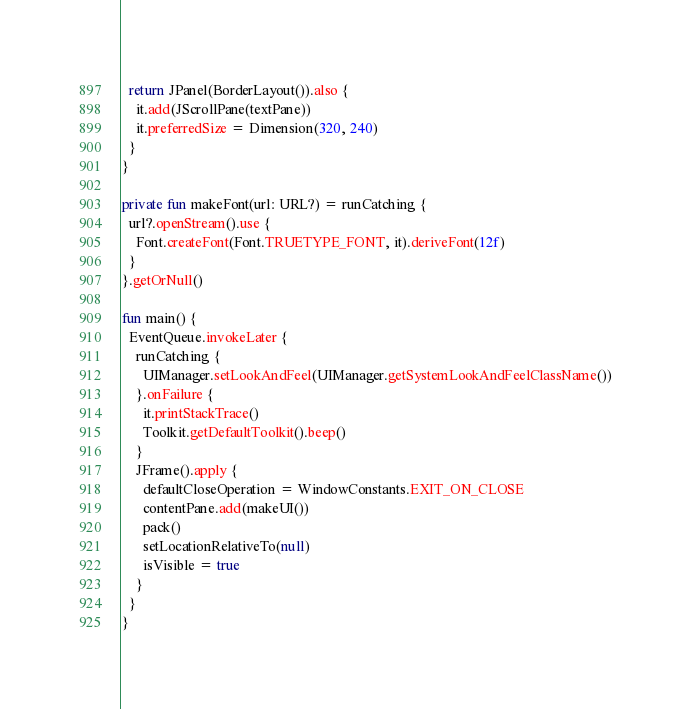<code> <loc_0><loc_0><loc_500><loc_500><_Kotlin_>  return JPanel(BorderLayout()).also {
    it.add(JScrollPane(textPane))
    it.preferredSize = Dimension(320, 240)
  }
}

private fun makeFont(url: URL?) = runCatching {
  url?.openStream().use {
    Font.createFont(Font.TRUETYPE_FONT, it).deriveFont(12f)
  }
}.getOrNull()

fun main() {
  EventQueue.invokeLater {
    runCatching {
      UIManager.setLookAndFeel(UIManager.getSystemLookAndFeelClassName())
    }.onFailure {
      it.printStackTrace()
      Toolkit.getDefaultToolkit().beep()
    }
    JFrame().apply {
      defaultCloseOperation = WindowConstants.EXIT_ON_CLOSE
      contentPane.add(makeUI())
      pack()
      setLocationRelativeTo(null)
      isVisible = true
    }
  }
}
</code> 